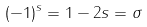Convert formula to latex. <formula><loc_0><loc_0><loc_500><loc_500>( - 1 ) ^ { s } = 1 - 2 s = \sigma</formula> 